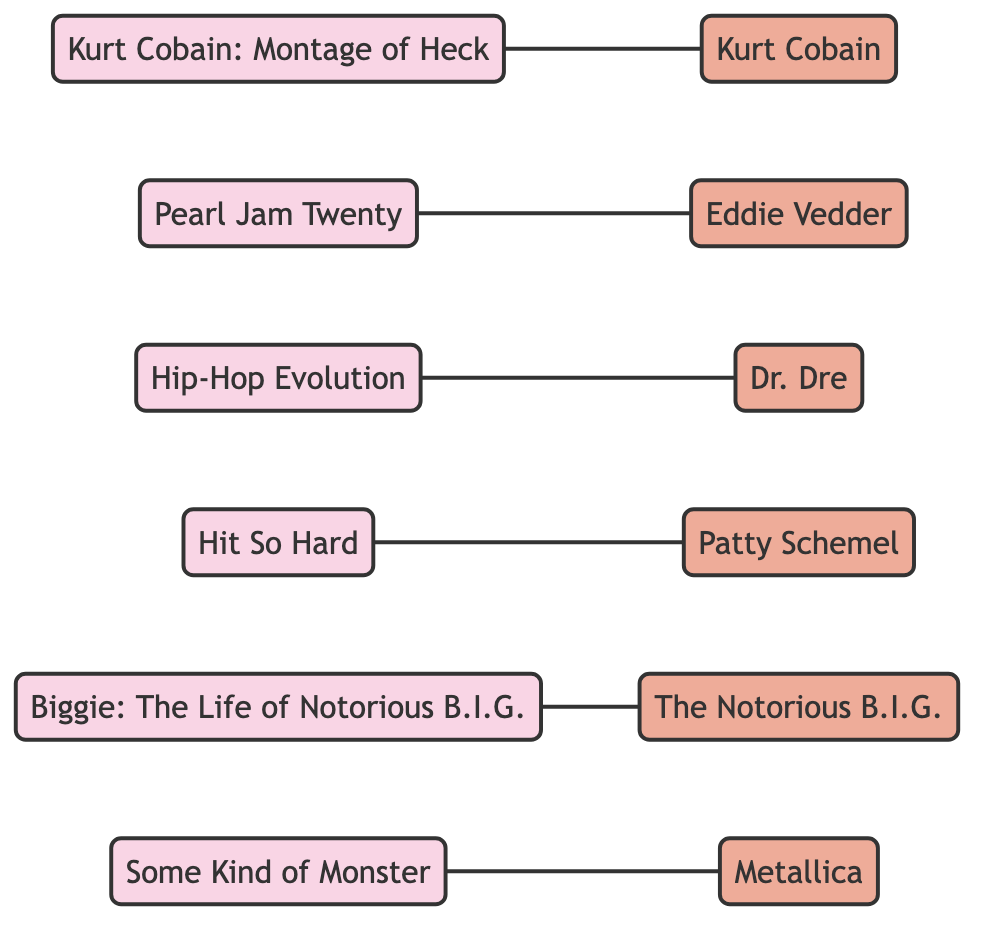What is the total number of documentaries in the diagram? There are six nodes labeled as documentaries: "Kurt Cobain: Montage of Heck," "Pearl Jam Twenty," "Hip-Hop Evolution," "Hit So Hard," "Biggie: The Life of Notorious B.I.G.," and "Some Kind of Monster." Counting these, we find there are a total of six documentaries.
Answer: 6 Who is directly connected to Eddie Vedder? Eddie Vedder is directly connected to "Pearl Jam Twenty," as per the edge that links them. This means "Pearl Jam Twenty" is the documentary associated with him.
Answer: Pearl Jam Twenty Which figure is associated with the documentary "Hip-Hop Evolution"? The documentary "Hip-Hop Evolution" is linked directly to the figure "Dr. Dre," as indicated by the edge connecting them in the diagram.
Answer: Dr. Dre How many figures are present in this web of documentaries? Counting all the distinct figures listed, we have: "Kurt Cobain," "Eddie Vedder," "Dr. Dre," "Patty Schemel," "The Notorious B.I.G.," and "Metallica." That totals six figures in the diagram.
Answer: 6 What is the relationship between "Hit So Hard" and "Patty Schemel"? "Hit So Hard" is a documentary that is directly connected to "Patty Schemel," indicating that the documentary features her. Thus, the relationship is that she is the figure connected to this documentary.
Answer: Patty Schemel Which documentary is related to The Notorious B.I.G.? The documentary that is related to The Notorious B.I.G. is "Biggie: The Life of Notorious B.I.G.," as shown by the connecting edge in the diagram.
Answer: Biggie: The Life of Notorious B.I.G How many total edges are present in the diagram? The edges indicate the connections between documentaries and figures. There are six pairs of connections displayed as edges, thus the total count of edges in the diagram is six.
Answer: 6 Is there a documentary that features both Kurt Cobain and a specific figure? Yes, the documentary "Kurt Cobain: Montage of Heck" features the figure "Kurt Cobain" directly connected to it through an edge in the diagram.
Answer: Kurt Cobain 